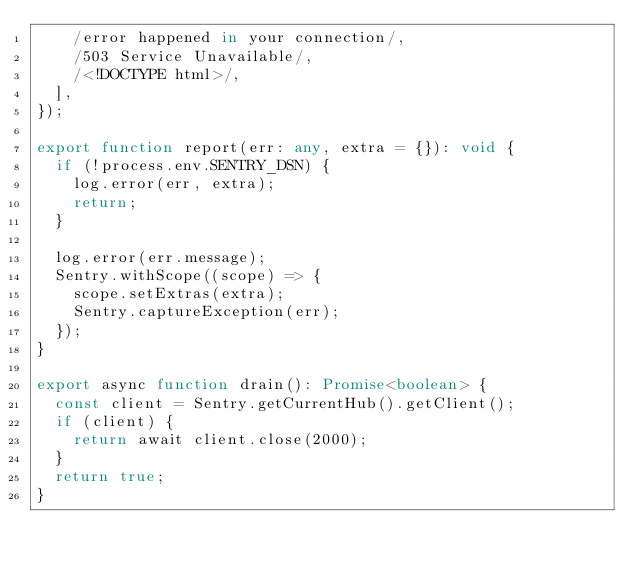Convert code to text. <code><loc_0><loc_0><loc_500><loc_500><_TypeScript_>    /error happened in your connection/,
    /503 Service Unavailable/,
    /<!DOCTYPE html>/,
  ],
});

export function report(err: any, extra = {}): void {
  if (!process.env.SENTRY_DSN) {
    log.error(err, extra);
    return;
  }

  log.error(err.message);
  Sentry.withScope((scope) => {
    scope.setExtras(extra);
    Sentry.captureException(err);
  });
}

export async function drain(): Promise<boolean> {
  const client = Sentry.getCurrentHub().getClient();
  if (client) {
    return await client.close(2000);
  }
  return true;
}
</code> 